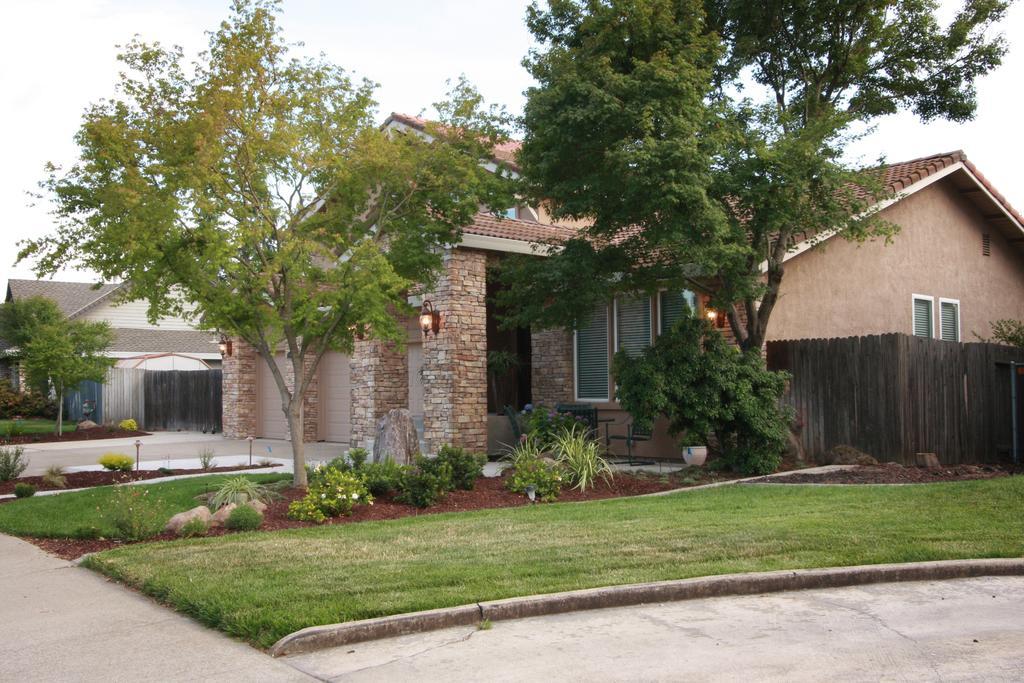Could you give a brief overview of what you see in this image? In this image I can see few buildings in-front of that there are some trees and plants. 